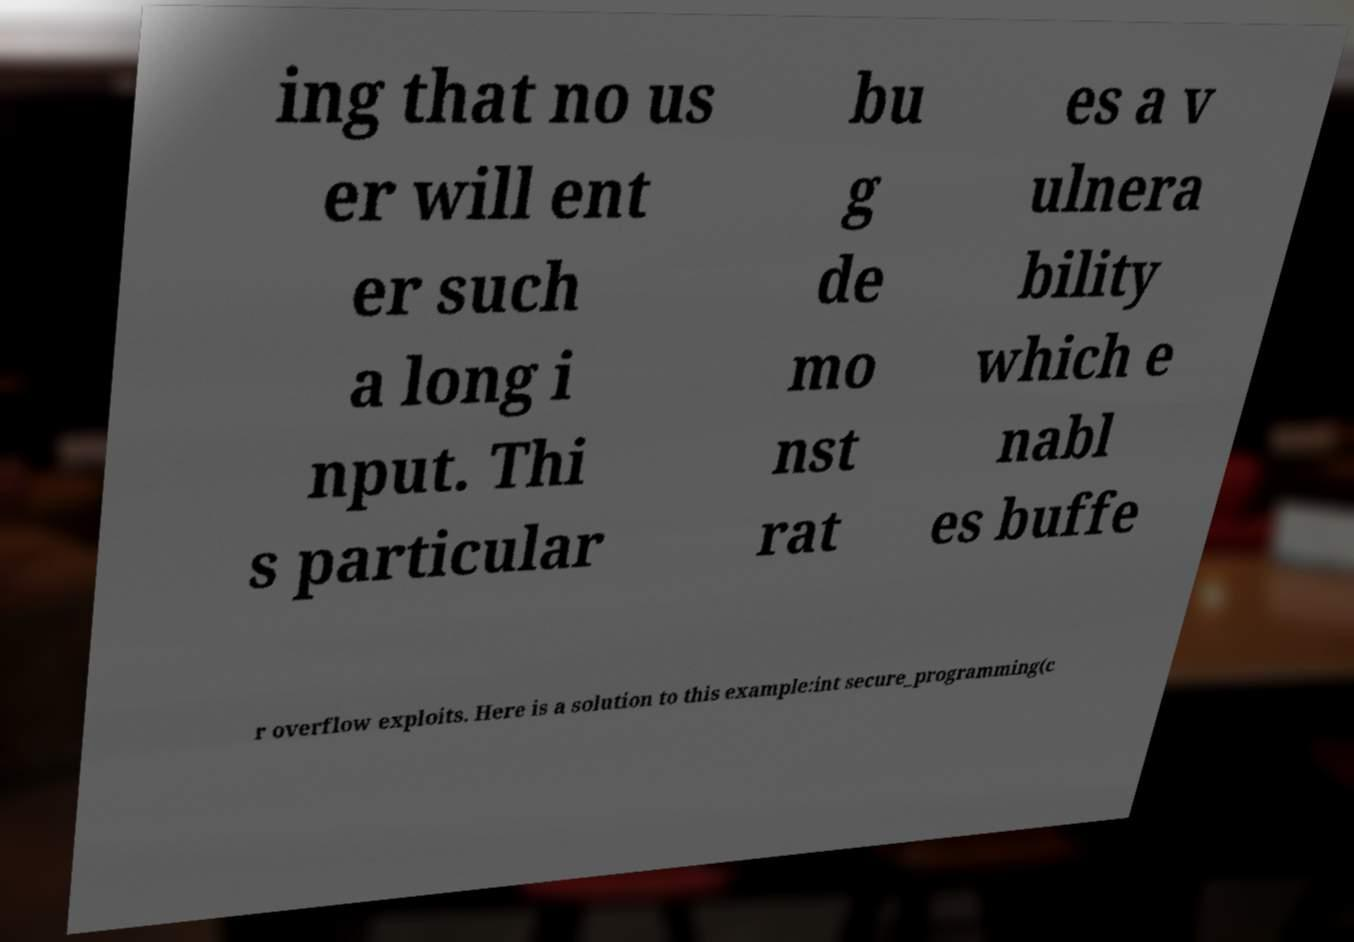There's text embedded in this image that I need extracted. Can you transcribe it verbatim? ing that no us er will ent er such a long i nput. Thi s particular bu g de mo nst rat es a v ulnera bility which e nabl es buffe r overflow exploits. Here is a solution to this example:int secure_programming(c 